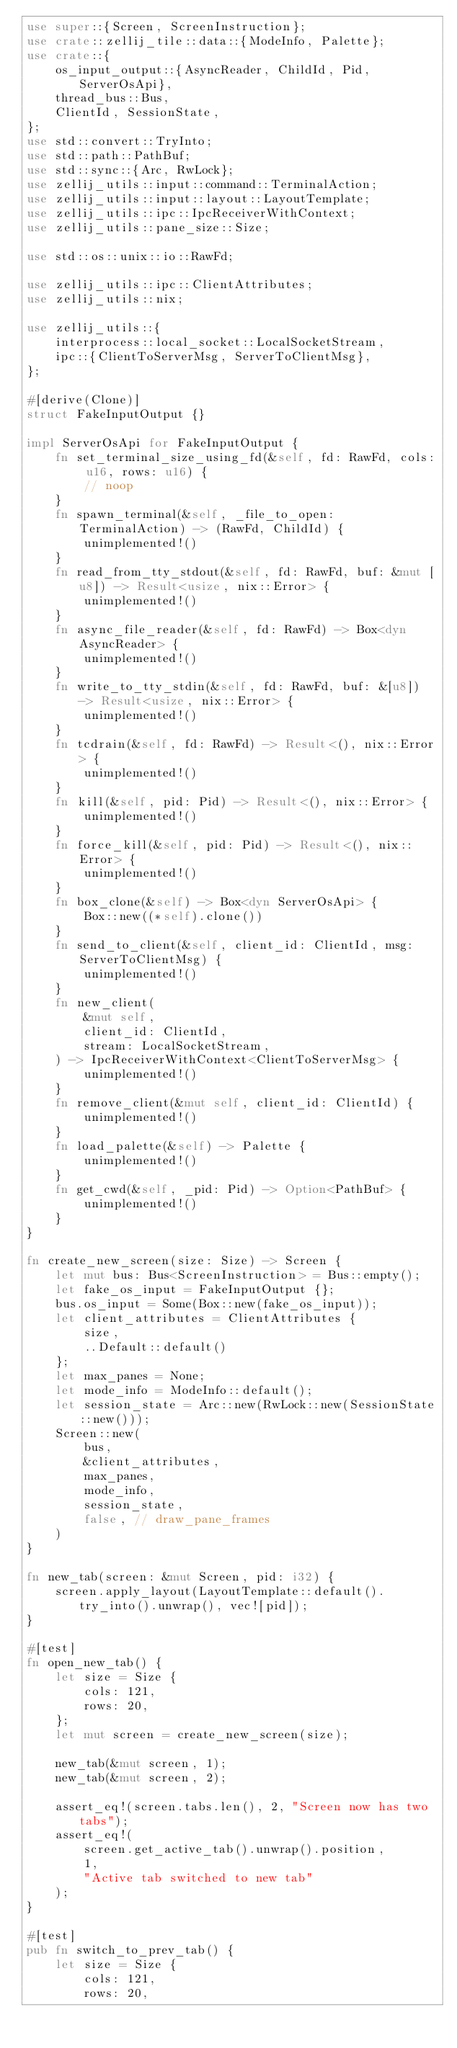<code> <loc_0><loc_0><loc_500><loc_500><_Rust_>use super::{Screen, ScreenInstruction};
use crate::zellij_tile::data::{ModeInfo, Palette};
use crate::{
    os_input_output::{AsyncReader, ChildId, Pid, ServerOsApi},
    thread_bus::Bus,
    ClientId, SessionState,
};
use std::convert::TryInto;
use std::path::PathBuf;
use std::sync::{Arc, RwLock};
use zellij_utils::input::command::TerminalAction;
use zellij_utils::input::layout::LayoutTemplate;
use zellij_utils::ipc::IpcReceiverWithContext;
use zellij_utils::pane_size::Size;

use std::os::unix::io::RawFd;

use zellij_utils::ipc::ClientAttributes;
use zellij_utils::nix;

use zellij_utils::{
    interprocess::local_socket::LocalSocketStream,
    ipc::{ClientToServerMsg, ServerToClientMsg},
};

#[derive(Clone)]
struct FakeInputOutput {}

impl ServerOsApi for FakeInputOutput {
    fn set_terminal_size_using_fd(&self, fd: RawFd, cols: u16, rows: u16) {
        // noop
    }
    fn spawn_terminal(&self, _file_to_open: TerminalAction) -> (RawFd, ChildId) {
        unimplemented!()
    }
    fn read_from_tty_stdout(&self, fd: RawFd, buf: &mut [u8]) -> Result<usize, nix::Error> {
        unimplemented!()
    }
    fn async_file_reader(&self, fd: RawFd) -> Box<dyn AsyncReader> {
        unimplemented!()
    }
    fn write_to_tty_stdin(&self, fd: RawFd, buf: &[u8]) -> Result<usize, nix::Error> {
        unimplemented!()
    }
    fn tcdrain(&self, fd: RawFd) -> Result<(), nix::Error> {
        unimplemented!()
    }
    fn kill(&self, pid: Pid) -> Result<(), nix::Error> {
        unimplemented!()
    }
    fn force_kill(&self, pid: Pid) -> Result<(), nix::Error> {
        unimplemented!()
    }
    fn box_clone(&self) -> Box<dyn ServerOsApi> {
        Box::new((*self).clone())
    }
    fn send_to_client(&self, client_id: ClientId, msg: ServerToClientMsg) {
        unimplemented!()
    }
    fn new_client(
        &mut self,
        client_id: ClientId,
        stream: LocalSocketStream,
    ) -> IpcReceiverWithContext<ClientToServerMsg> {
        unimplemented!()
    }
    fn remove_client(&mut self, client_id: ClientId) {
        unimplemented!()
    }
    fn load_palette(&self) -> Palette {
        unimplemented!()
    }
    fn get_cwd(&self, _pid: Pid) -> Option<PathBuf> {
        unimplemented!()
    }
}

fn create_new_screen(size: Size) -> Screen {
    let mut bus: Bus<ScreenInstruction> = Bus::empty();
    let fake_os_input = FakeInputOutput {};
    bus.os_input = Some(Box::new(fake_os_input));
    let client_attributes = ClientAttributes {
        size,
        ..Default::default()
    };
    let max_panes = None;
    let mode_info = ModeInfo::default();
    let session_state = Arc::new(RwLock::new(SessionState::new()));
    Screen::new(
        bus,
        &client_attributes,
        max_panes,
        mode_info,
        session_state,
        false, // draw_pane_frames
    )
}

fn new_tab(screen: &mut Screen, pid: i32) {
    screen.apply_layout(LayoutTemplate::default().try_into().unwrap(), vec![pid]);
}

#[test]
fn open_new_tab() {
    let size = Size {
        cols: 121,
        rows: 20,
    };
    let mut screen = create_new_screen(size);

    new_tab(&mut screen, 1);
    new_tab(&mut screen, 2);

    assert_eq!(screen.tabs.len(), 2, "Screen now has two tabs");
    assert_eq!(
        screen.get_active_tab().unwrap().position,
        1,
        "Active tab switched to new tab"
    );
}

#[test]
pub fn switch_to_prev_tab() {
    let size = Size {
        cols: 121,
        rows: 20,</code> 